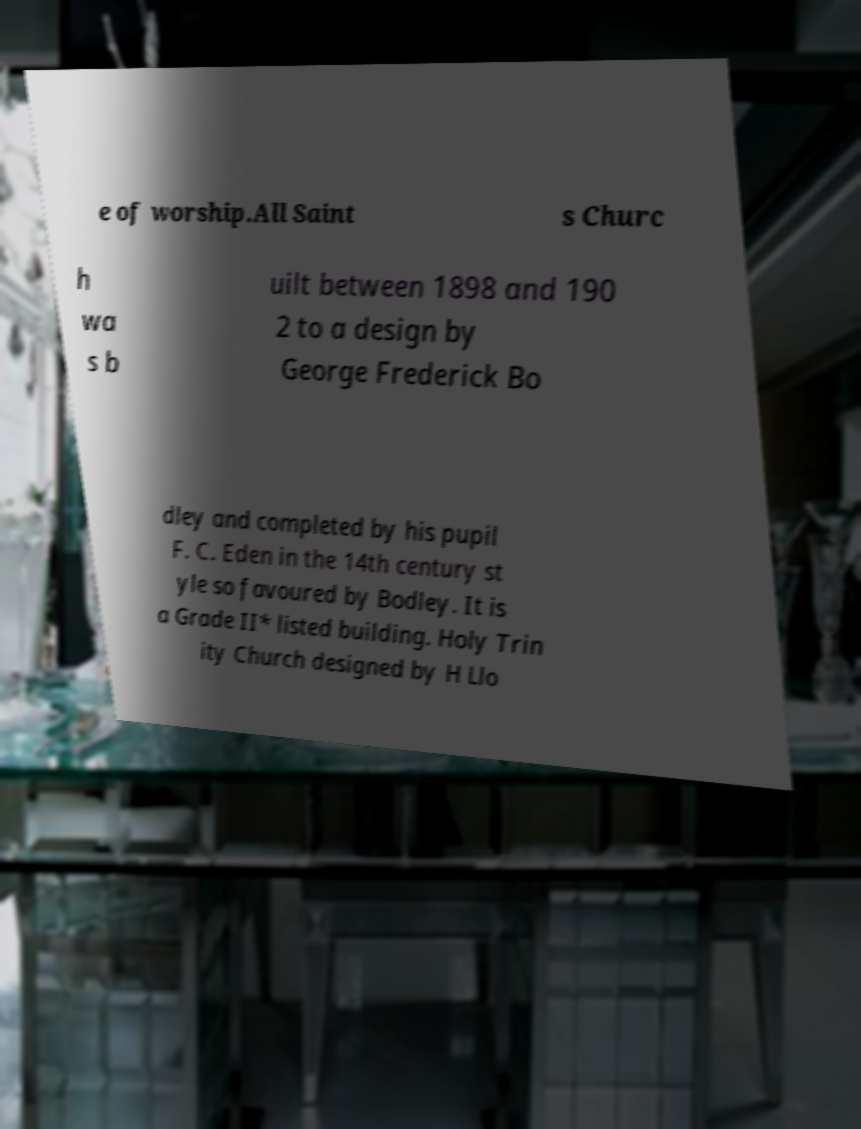For documentation purposes, I need the text within this image transcribed. Could you provide that? e of worship.All Saint s Churc h wa s b uilt between 1898 and 190 2 to a design by George Frederick Bo dley and completed by his pupil F. C. Eden in the 14th century st yle so favoured by Bodley. It is a Grade II* listed building. Holy Trin ity Church designed by H Llo 